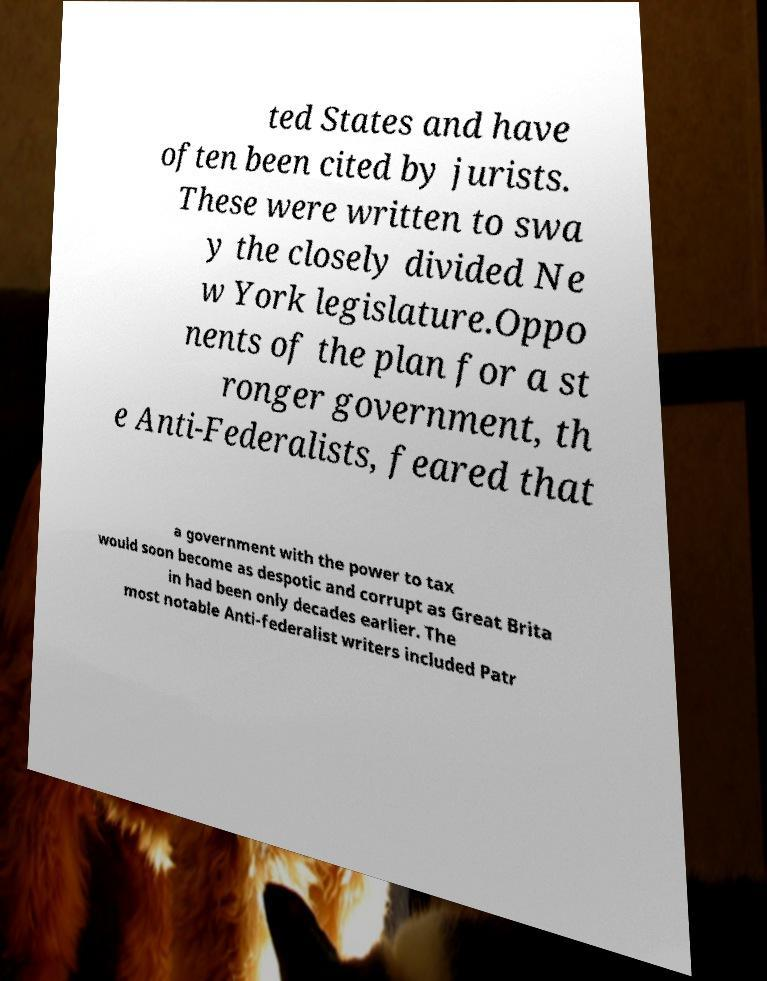Can you read and provide the text displayed in the image?This photo seems to have some interesting text. Can you extract and type it out for me? ted States and have often been cited by jurists. These were written to swa y the closely divided Ne w York legislature.Oppo nents of the plan for a st ronger government, th e Anti-Federalists, feared that a government with the power to tax would soon become as despotic and corrupt as Great Brita in had been only decades earlier. The most notable Anti-federalist writers included Patr 